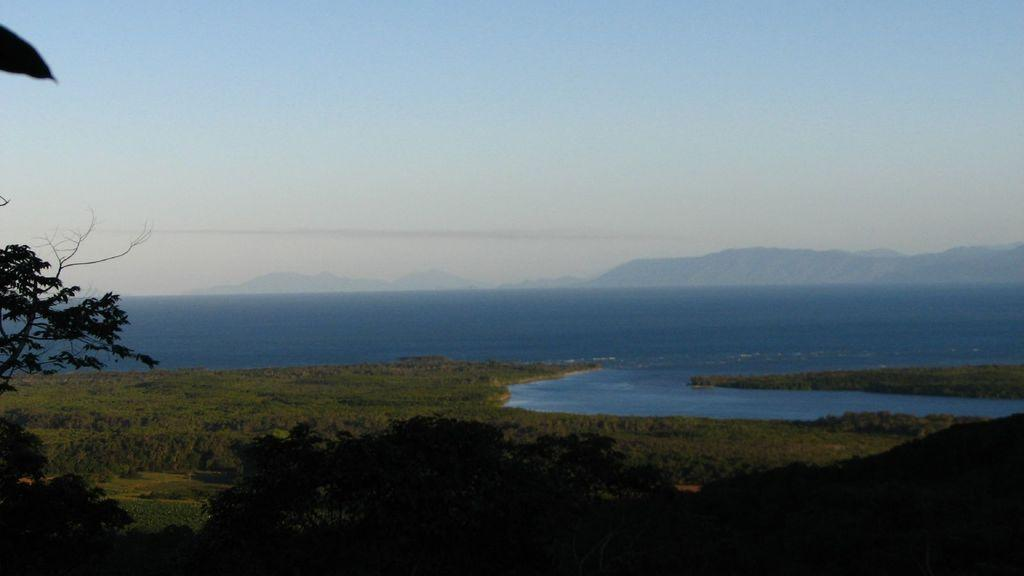What type of vegetation can be seen in the image? There is grass in the image. What color is the grass? The grass is green. What other natural elements are present in the image? There are trees in the image. What color are the trees? The trees are green. What body of water is visible in the image? There is water visible in the image. What color is the water? The water is blue. What part of the sky is visible in the image? The sky is visible in the image. What colors can be seen in the sky? The sky is blue and white. What advice does the manager give to the father about their child's crush in the image? There is no mention of a father, manager, or crush in the image; it features grass, trees, water, and a blue and white sky. 